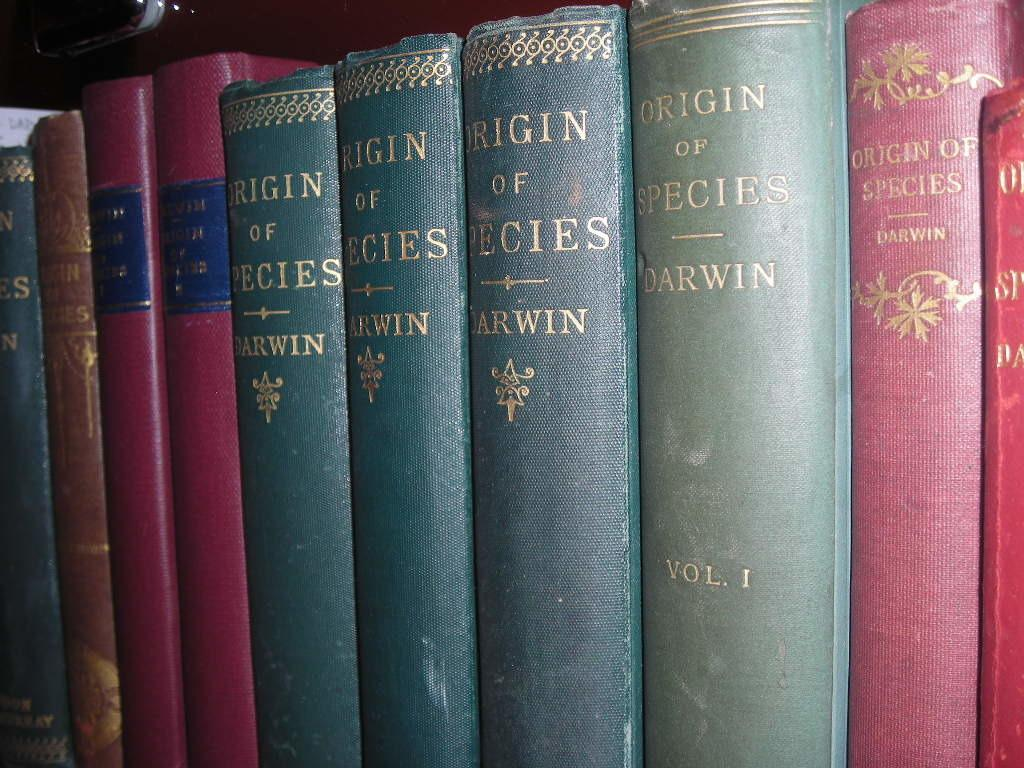What type of objects can be seen in the image? There are books in the image. How many cherries are on top of the books in the image? There are no cherries present in the image; it only features books. Can you describe the man reading a book in the image? There is no man present in the image; it only features books. 